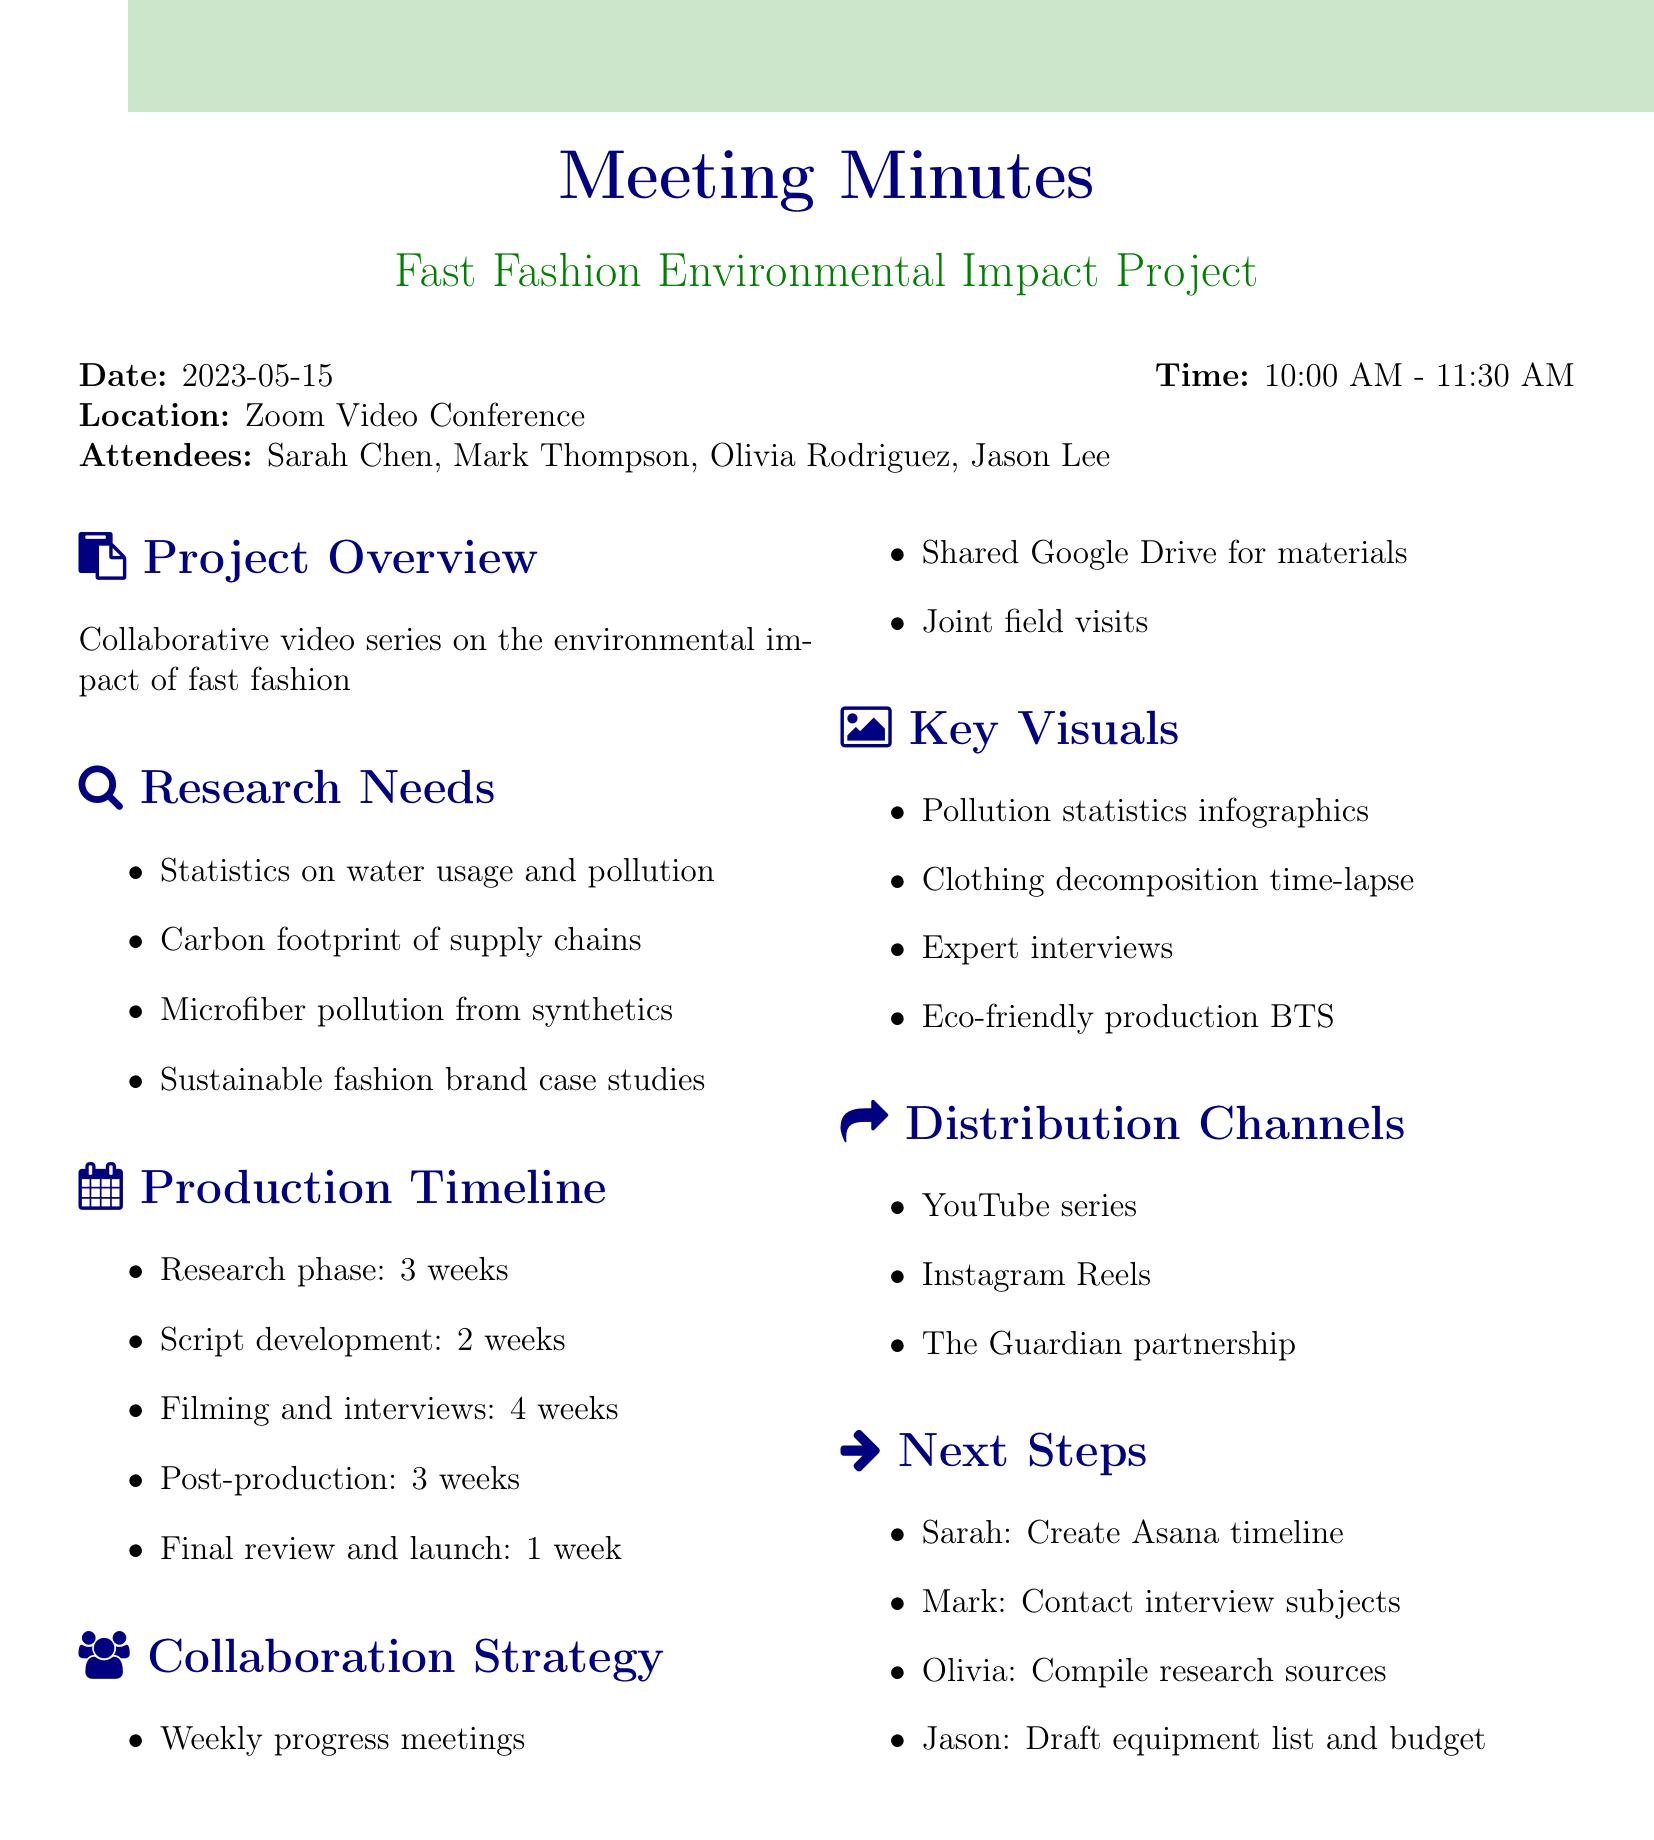What is the date of the meeting? The date of the meeting is stated clearly at the beginning of the document.
Answer: 2023-05-15 Who is the production manager? The production manager is listed among the attendees of the meeting.
Answer: Jason Lee How long is the research phase? The duration of the research phase is specified in the production timeline section.
Answer: 3 weeks What is one key visual that will be used in the video series? The document lists several key visuals that will be used in the project.
Answer: Infographics on fashion industry pollution statistics What is the first next step assigned to Sarah? Sarah's next step is mentioned in the next steps section of the document.
Answer: Create project timeline in Asana How many total weeks are planned for filming and post-production combined? The total weeks can be calculated by adding the weeks allocated for filming and post-production from the timeline.
Answer: 7 weeks What is the purpose of the collaborative project? The document provides a brief overview of the project at the beginning.
Answer: Environmental impact of fast fashion What is the distribution channel focused on Instagram? The distribution channels are listed clearly in the document, specifying different platforms.
Answer: Instagram Reels 